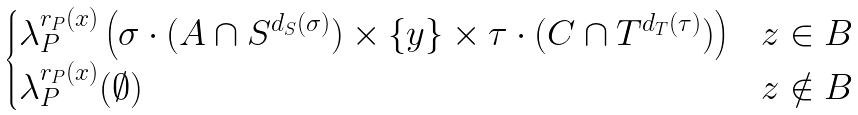<formula> <loc_0><loc_0><loc_500><loc_500>\begin{cases} \lambda _ { P } ^ { r _ { P } ( x ) } \left ( \sigma \cdot ( A \cap S ^ { d _ { S } ( \sigma ) } ) \times \{ y \} \times \tau \cdot ( C \cap T ^ { d _ { T } ( \tau ) } ) \right ) & z \in B \\ \lambda _ { P } ^ { r _ { P } ( x ) } ( \emptyset ) & z \notin B \end{cases}</formula> 